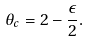<formula> <loc_0><loc_0><loc_500><loc_500>\theta _ { c } = 2 - \frac { \epsilon } { 2 } .</formula> 